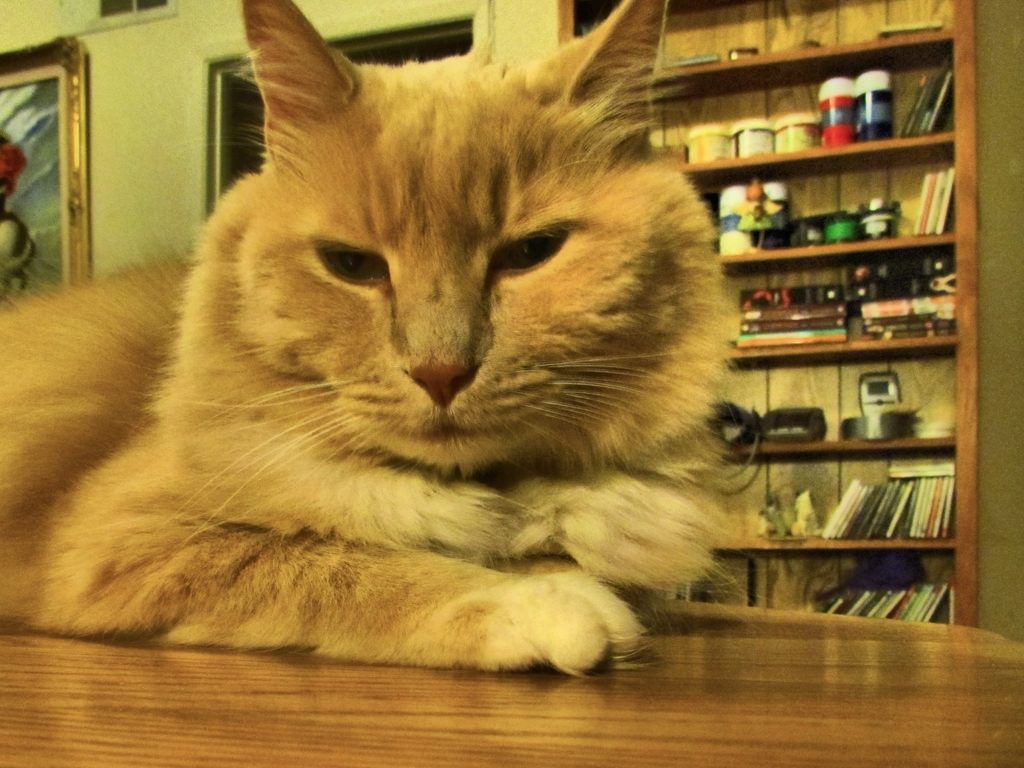What breed of cat is this? The cat in the image resembles a domestic shorthair, characterized by its plush coat and strong build, typical of a well-loved pet. However, identifying specific breeds through an image alone can be challenging without pedigree information. 